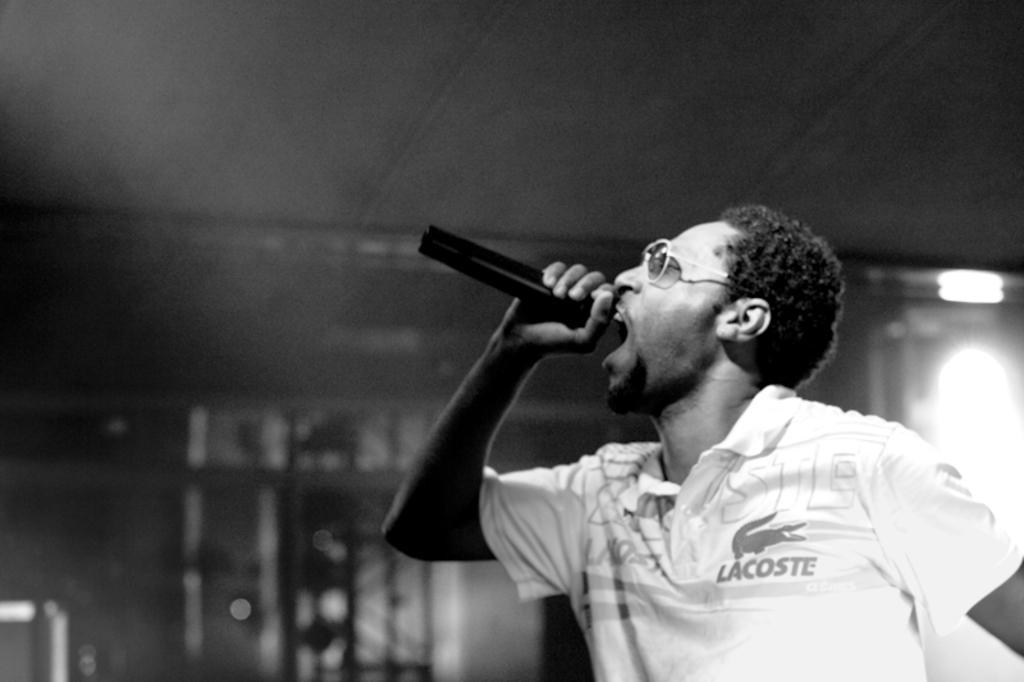Describe this image in one or two sentences. Black and white picture. This man is holding mic and singing. 